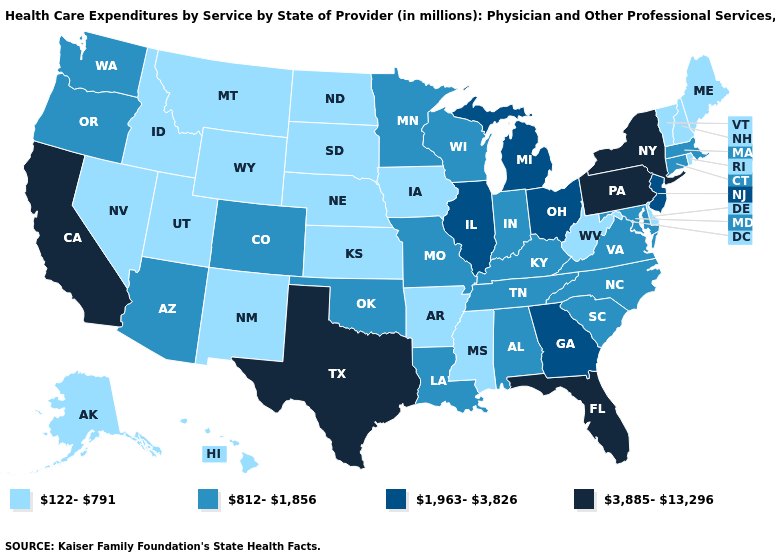Does Arkansas have a lower value than New Hampshire?
Quick response, please. No. What is the value of Pennsylvania?
Be succinct. 3,885-13,296. Which states have the highest value in the USA?
Keep it brief. California, Florida, New York, Pennsylvania, Texas. Does Illinois have the highest value in the USA?
Answer briefly. No. Which states have the lowest value in the West?
Answer briefly. Alaska, Hawaii, Idaho, Montana, Nevada, New Mexico, Utah, Wyoming. Does Massachusetts have the highest value in the Northeast?
Short answer required. No. What is the lowest value in states that border Indiana?
Quick response, please. 812-1,856. Name the states that have a value in the range 3,885-13,296?
Write a very short answer. California, Florida, New York, Pennsylvania, Texas. What is the highest value in states that border Kansas?
Answer briefly. 812-1,856. Name the states that have a value in the range 1,963-3,826?
Answer briefly. Georgia, Illinois, Michigan, New Jersey, Ohio. Among the states that border Arkansas , which have the highest value?
Quick response, please. Texas. What is the highest value in states that border Vermont?
Answer briefly. 3,885-13,296. Among the states that border Tennessee , does Kentucky have the lowest value?
Write a very short answer. No. Does the first symbol in the legend represent the smallest category?
Give a very brief answer. Yes. Does Arizona have a lower value than North Carolina?
Short answer required. No. 